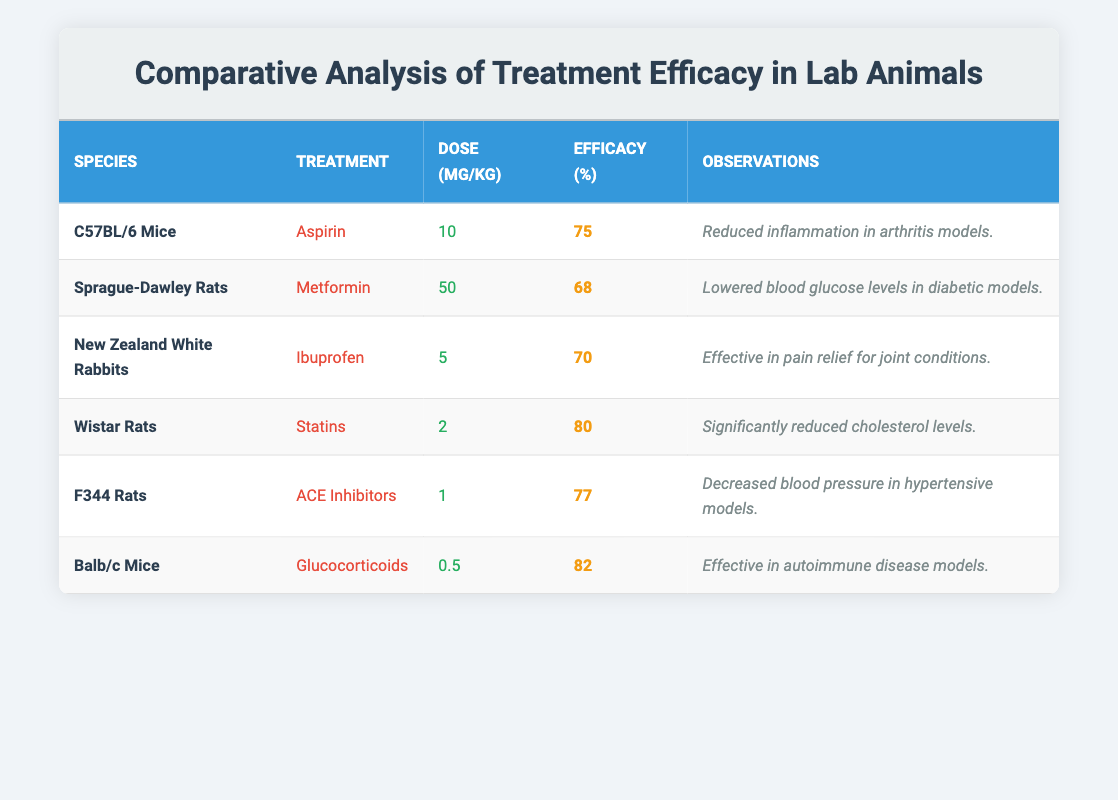What is the efficacy percentage of Aspirin in C57BL/6 Mice? The efficacy percentage for Aspirin in C57BL/6 Mice is located in the corresponding row under the "Efficacy (%)" column, which shows 75 percent.
Answer: 75 What treatment had the highest efficacy among the listed treatments? By examining the "Efficacy (%)" column for each treatment, the highest value is 82 percent for Glucocorticoids in Balb/c Mice.
Answer: 82 How many milligrams per kilogram of ACE Inhibitors were administered to F344 Rats? The dose for ACE Inhibitors in F344 Rats is shown in the "Dose (mg/kg)" column, which states 1 mg per kg.
Answer: 1 Which treatment was used on Wistar Rats and what was its efficacy percentage? Wistar Rats received Statins, and their efficacy percentage is noted in the "Efficacy (%)" column, showing 80 percent.
Answer: Statins, 80 Is the efficacy of Metformin in Sprague-Dawley Rats greater than 70 percent? The efficacy percentage for Metformin in Sprague-Dawley Rats is 68 percent, which is less than 70 percent, making the statement false.
Answer: No What is the average efficacy percentage of all treatments listed in the table? Adding all efficacy percentages: 75 + 68 + 70 + 80 + 77 + 82 = 452. Dividing by the number of treatments (6) gives: 452 / 6 = 75.33. Therefore, the average is approximately 75.33 percent.
Answer: 75.33 Which species had the lowest treatment dose and what was the treatment? The lowest treatment dose listed is 0.5 mg/kg for Glucocorticoids in Balb/c Mice. This information is found in the "Dose (mg/kg)" column.
Answer: Balb/c Mice, Glucocorticoids How many species achieved an efficacy percentage of 75 or higher? Analyzing the "Efficacy (%)" column, the species with 75 or higher are C57BL/6 Mice, Wistar Rats, F344 Rats, and Balb/c Mice. Counting these rows gives a total of 4 species.
Answer: 4 Did New Zealand White Rabbits show greater efficacy with Ibuprofen than Sprague-Dawley Rats with Metformin? The efficacy for Ibuprofen in New Zealand White Rabbits is 70 percent, while the efficacy for Metformin in Sprague-Dawley Rats is 68 percent. Since 70 is greater than 68, the answer is yes.
Answer: Yes 